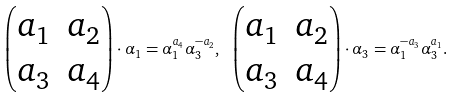<formula> <loc_0><loc_0><loc_500><loc_500>\begin{pmatrix} a _ { 1 } & a _ { 2 } \\ a _ { 3 } & a _ { 4 } \end{pmatrix} \cdot \alpha _ { 1 } = \alpha _ { 1 } ^ { a _ { 4 } } \alpha _ { 3 } ^ { - a _ { 2 } } , \ \begin{pmatrix} a _ { 1 } & a _ { 2 } \\ a _ { 3 } & a _ { 4 } \end{pmatrix} \cdot \alpha _ { 3 } = \alpha _ { 1 } ^ { - a _ { 3 } } \alpha _ { 3 } ^ { a _ { 1 } } .</formula> 